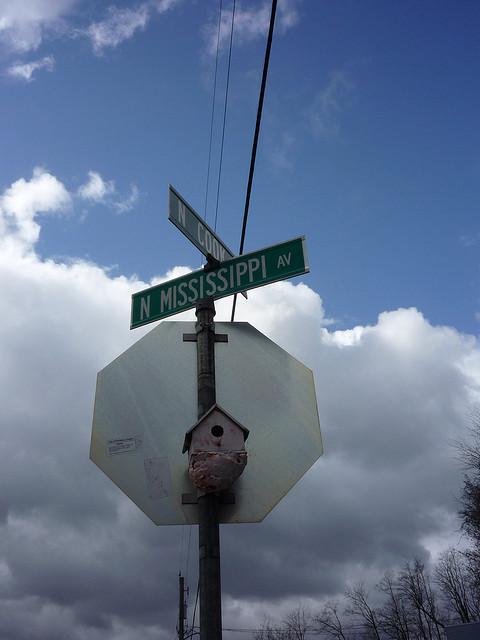Are there clouds?
Concise answer only. Yes. What is the color of the sky?
Write a very short answer. Blue. What is one of the two streets at this crossroad?
Give a very brief answer. N mississippi av. 